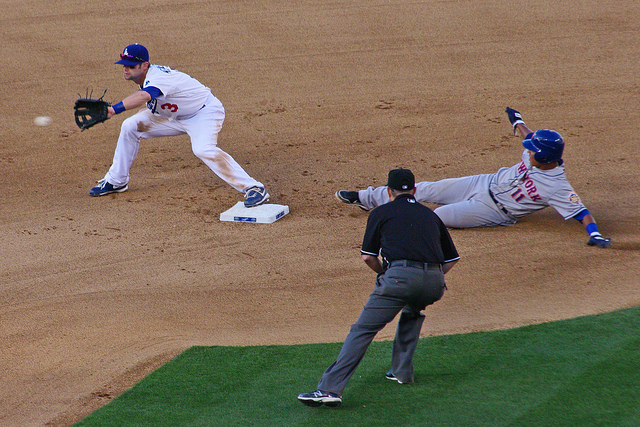Identify and read out the text in this image. YORK 3 